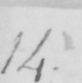Transcribe the text shown in this historical manuscript line. 14 . 